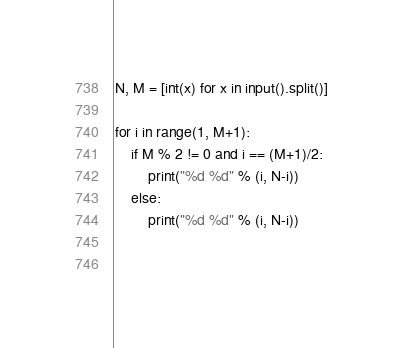Convert code to text. <code><loc_0><loc_0><loc_500><loc_500><_Python_>N, M = [int(x) for x in input().split()]

for i in range(1, M+1):
    if M % 2 != 0 and i == (M+1)/2:
        print("%d %d" % (i, N-i))
    else:
        print("%d %d" % (i, N-i))
        
        
</code> 